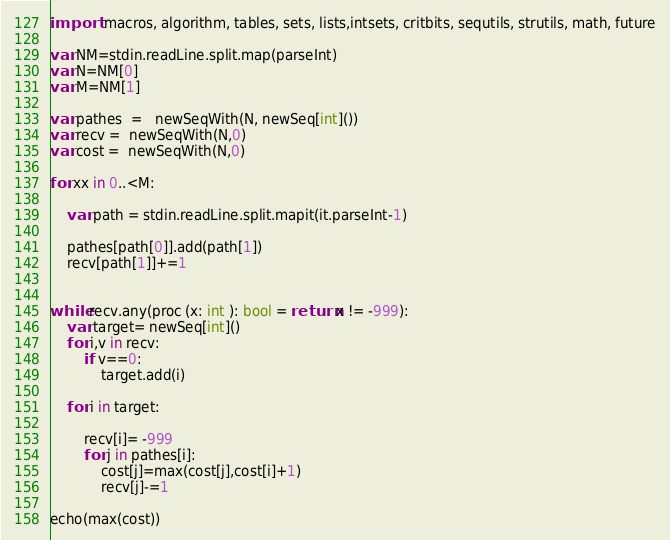Convert code to text. <code><loc_0><loc_0><loc_500><loc_500><_Nim_>import  macros, algorithm, tables, sets, lists,intsets, critbits, sequtils, strutils, math, future

var NM=stdin.readLine.split.map(parseInt)
var N=NM[0]
var M=NM[1]

var pathes  =   newSeqWith(N, newSeq[int]())
var recv =  newSeqWith(N,0)
var cost =  newSeqWith(N,0)

for xx in 0..<M:
    
    var path = stdin.readLine.split.mapit(it.parseInt-1)

    pathes[path[0]].add(path[1])
    recv[path[1]]+=1


while recv.any(proc (x: int ): bool = return x != -999):
    var target= newSeq[int]()
    for i,v in recv:
        if v==0:
            target.add(i)
    
    for i in target:
        
        recv[i]= -999
        for j in pathes[i]:
            cost[j]=max(cost[j],cost[i]+1)
            recv[j]-=1

echo(max(cost))</code> 